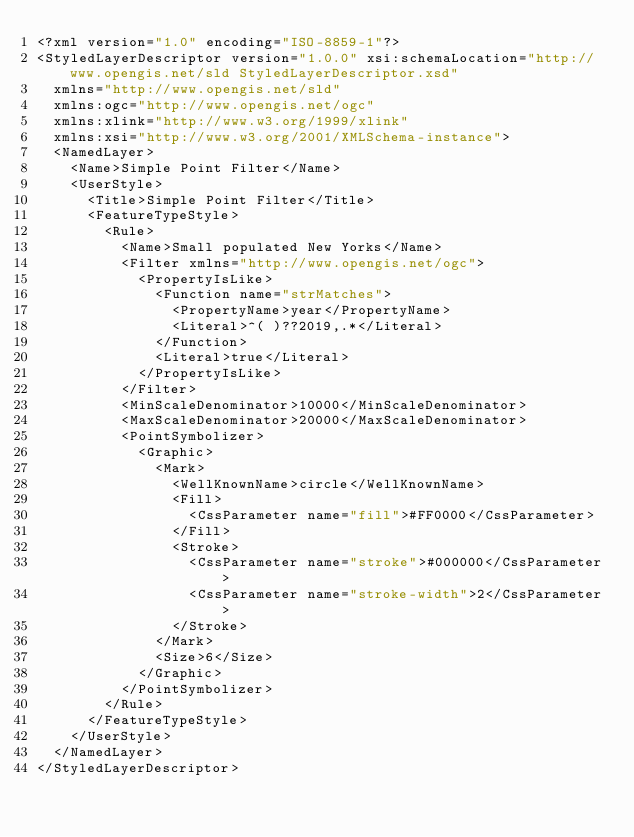<code> <loc_0><loc_0><loc_500><loc_500><_Scheme_><?xml version="1.0" encoding="ISO-8859-1"?>
<StyledLayerDescriptor version="1.0.0" xsi:schemaLocation="http://www.opengis.net/sld StyledLayerDescriptor.xsd"
  xmlns="http://www.opengis.net/sld"
  xmlns:ogc="http://www.opengis.net/ogc"
  xmlns:xlink="http://www.w3.org/1999/xlink"
  xmlns:xsi="http://www.w3.org/2001/XMLSchema-instance">
  <NamedLayer>
    <Name>Simple Point Filter</Name>
    <UserStyle>
      <Title>Simple Point Filter</Title>
      <FeatureTypeStyle>
        <Rule>
          <Name>Small populated New Yorks</Name>
          <Filter xmlns="http://www.opengis.net/ogc">
            <PropertyIsLike>
              <Function name="strMatches">
                <PropertyName>year</PropertyName>
                <Literal>^( )??2019,.*</Literal>
              </Function>
              <Literal>true</Literal>
            </PropertyIsLike>
          </Filter>
          <MinScaleDenominator>10000</MinScaleDenominator>
          <MaxScaleDenominator>20000</MaxScaleDenominator>
          <PointSymbolizer>
            <Graphic>
              <Mark>
                <WellKnownName>circle</WellKnownName>
                <Fill>
                  <CssParameter name="fill">#FF0000</CssParameter>
                </Fill>
                <Stroke>
                  <CssParameter name="stroke">#000000</CssParameter>
                  <CssParameter name="stroke-width">2</CssParameter>
                </Stroke>
              </Mark>
              <Size>6</Size>
            </Graphic>
          </PointSymbolizer>
        </Rule>
      </FeatureTypeStyle>
    </UserStyle>
  </NamedLayer>
</StyledLayerDescriptor>
</code> 